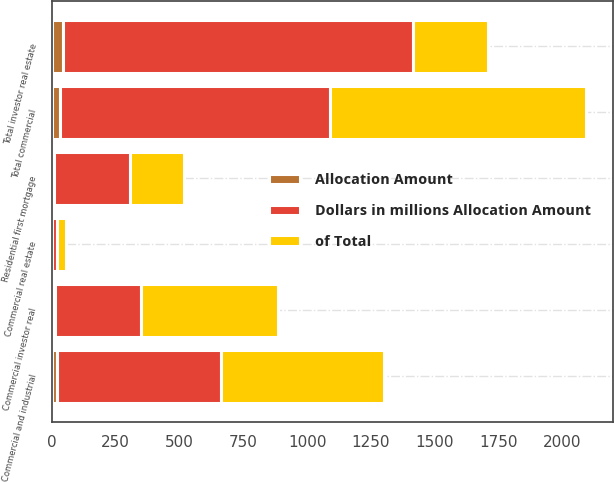Convert chart. <chart><loc_0><loc_0><loc_500><loc_500><stacked_bar_chart><ecel><fcel>Commercial and industrial<fcel>Commercial real estate<fcel>Total commercial<fcel>Commercial investor real<fcel>Total investor real estate<fcel>Residential first mortgage<nl><fcel>Dollars in millions Allocation Amount<fcel>641<fcel>19<fcel>1055<fcel>340<fcel>1370<fcel>295<nl><fcel>Allocation Amount<fcel>20.1<fcel>0.6<fcel>33.1<fcel>10.7<fcel>43<fcel>9.4<nl><fcel>of Total<fcel>638<fcel>37<fcel>1003<fcel>536<fcel>295<fcel>213<nl></chart> 